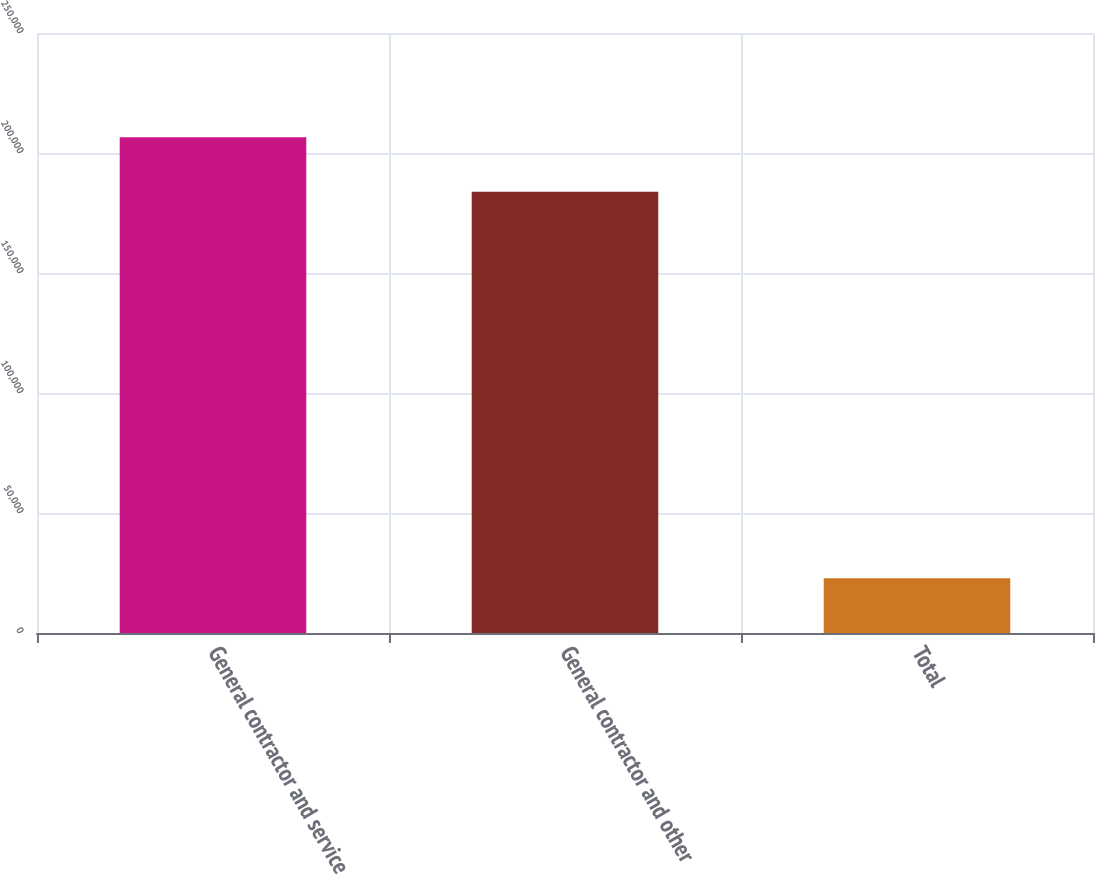Convert chart to OTSL. <chart><loc_0><loc_0><loc_500><loc_500><bar_chart><fcel>General contractor and service<fcel>General contractor and other<fcel>Total<nl><fcel>206596<fcel>183833<fcel>22763<nl></chart> 